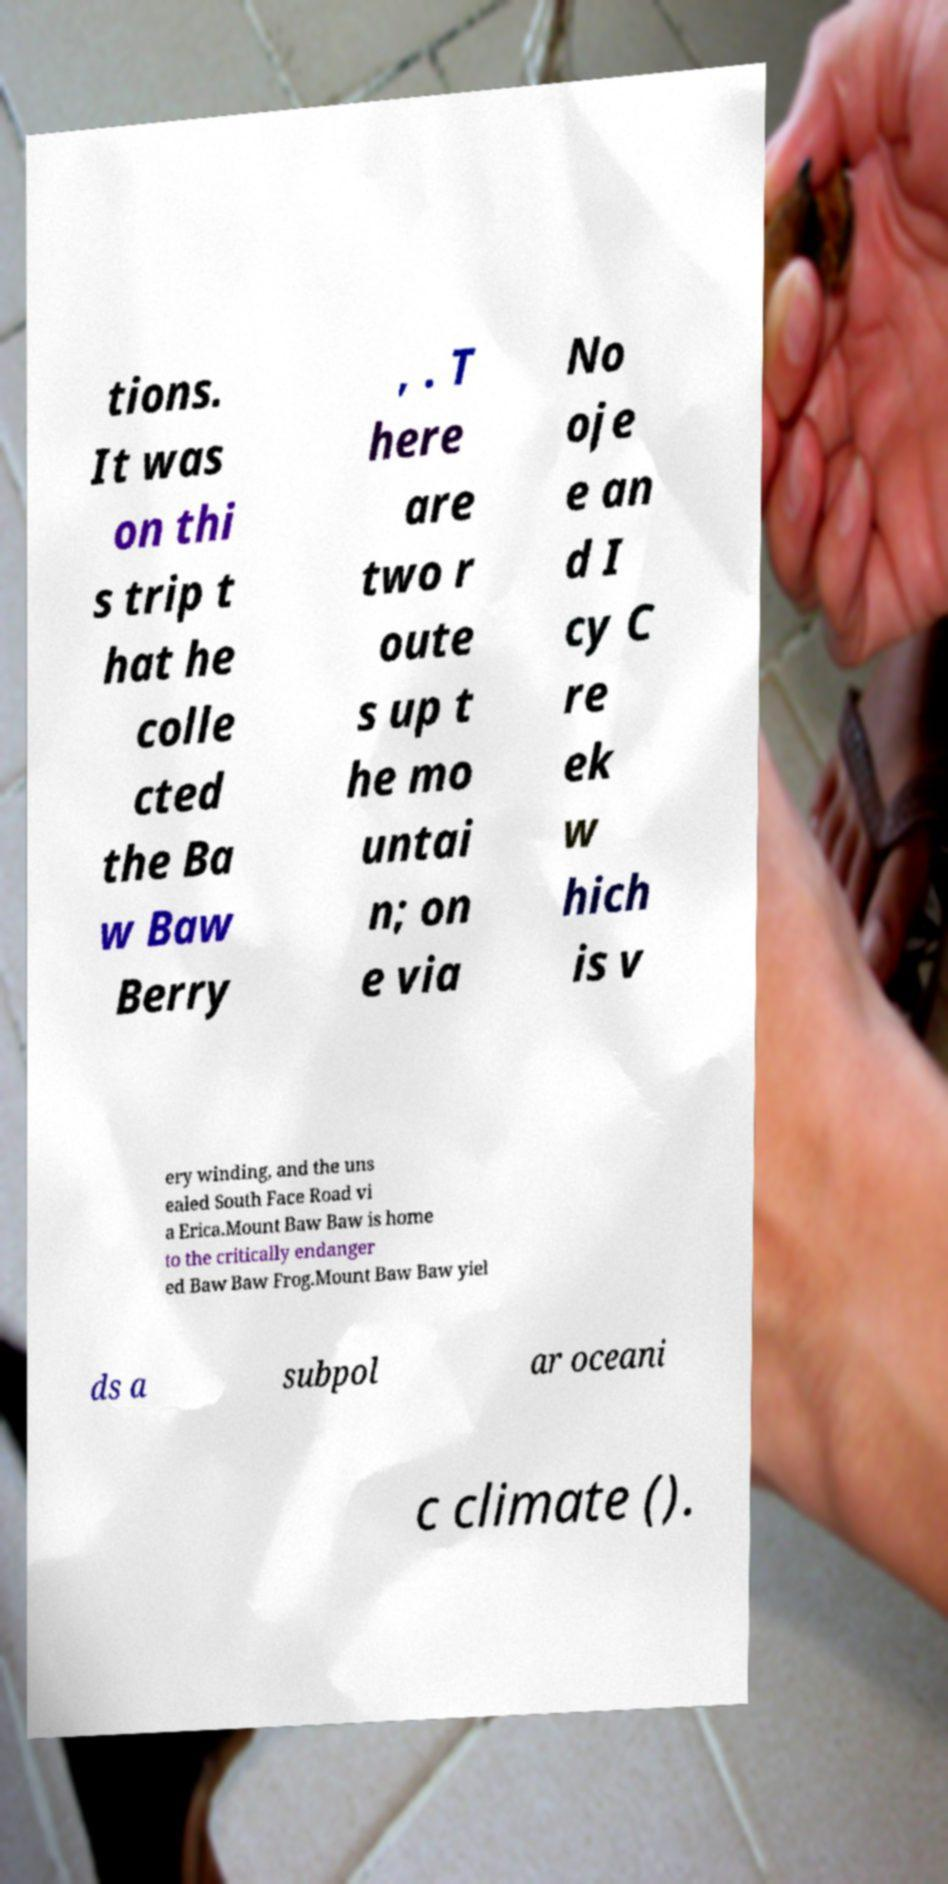Can you accurately transcribe the text from the provided image for me? tions. It was on thi s trip t hat he colle cted the Ba w Baw Berry , . T here are two r oute s up t he mo untai n; on e via No oje e an d I cy C re ek w hich is v ery winding, and the uns ealed South Face Road vi a Erica.Mount Baw Baw is home to the critically endanger ed Baw Baw Frog.Mount Baw Baw yiel ds a subpol ar oceani c climate (). 